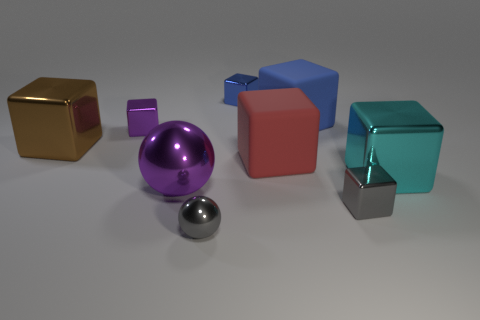Subtract all large shiny cubes. How many cubes are left? 5 Subtract 0 red cylinders. How many objects are left? 9 Subtract all balls. How many objects are left? 7 Subtract 7 cubes. How many cubes are left? 0 Subtract all red balls. Subtract all gray cylinders. How many balls are left? 2 Subtract all yellow cubes. How many cyan spheres are left? 0 Subtract all small yellow things. Subtract all large red blocks. How many objects are left? 8 Add 9 blue shiny things. How many blue shiny things are left? 10 Add 9 green things. How many green things exist? 9 Add 1 red matte blocks. How many objects exist? 10 